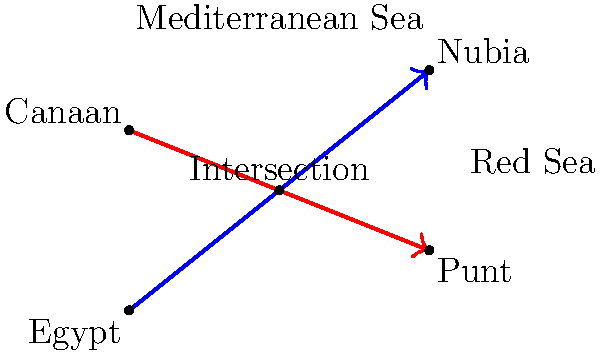In ancient times, two major trade routes connected Egypt with its neighboring civilizations. The first route, from Egypt to Nubia, can be represented by the line equation $y = \frac{4}{5}x$. The second route, from Canaan to Punt, is described by the line $y = -\frac{2}{5}x + 6$. At which point do these trade routes intersect, potentially indicating a significant location for cultural exchange and trade in the ancient world? To find the intersection point of these two trade routes, we need to solve the system of equations:

1) First route (Egypt to Nubia): $y = \frac{4}{5}x$
2) Second route (Canaan to Punt): $y = -\frac{2}{5}x + 6$

At the intersection point, the y-coordinates will be equal, so we can set the right sides of these equations equal to each other:

$$\frac{4}{5}x = -\frac{2}{5}x + 6$$

Now, let's solve for x:

$$\frac{4}{5}x + \frac{2}{5}x = 6$$
$$\frac{6}{5}x = 6$$
$$x = 5$$

To find the y-coordinate, we can substitute x = 5 into either of the original equations. Let's use the first one:

$$y = \frac{4}{5}(5) = 4$$

Therefore, the intersection point is (5, 4).

In the context of ancient Egyptian trade, this point could represent a crucial location where goods from Nubia, Canaan, and Punt might have been exchanged. It's worth noting that this mathematical model is a simplification and doesn't account for geographical features like the Nile River or the Red Sea, which would have significantly influenced actual trade routes.
Answer: (5, 4) 